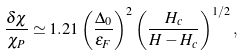Convert formula to latex. <formula><loc_0><loc_0><loc_500><loc_500>\frac { \delta \chi } { \chi _ { P } } \simeq 1 . 2 1 \left ( \frac { \Delta _ { 0 } } { \epsilon _ { F } } \right ) ^ { 2 } \left ( \frac { H _ { c } } { H - H _ { c } } \right ) ^ { 1 / 2 } ,</formula> 